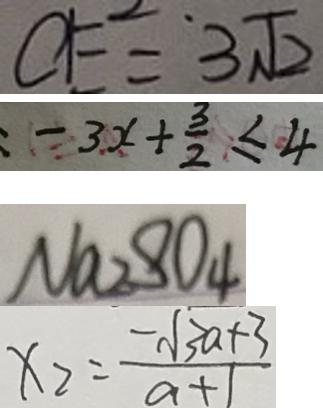<formula> <loc_0><loc_0><loc_500><loc_500>C E = 3 \sqrt { 2 } 
 = 3 x + \frac { 3 } { 2 } \leq 4 
 N a _ { 2 } S O _ { 4 } 
 x _ { 2 } = \frac { - \sqrt { 3 a + 3 } } { a + 1 }</formula> 